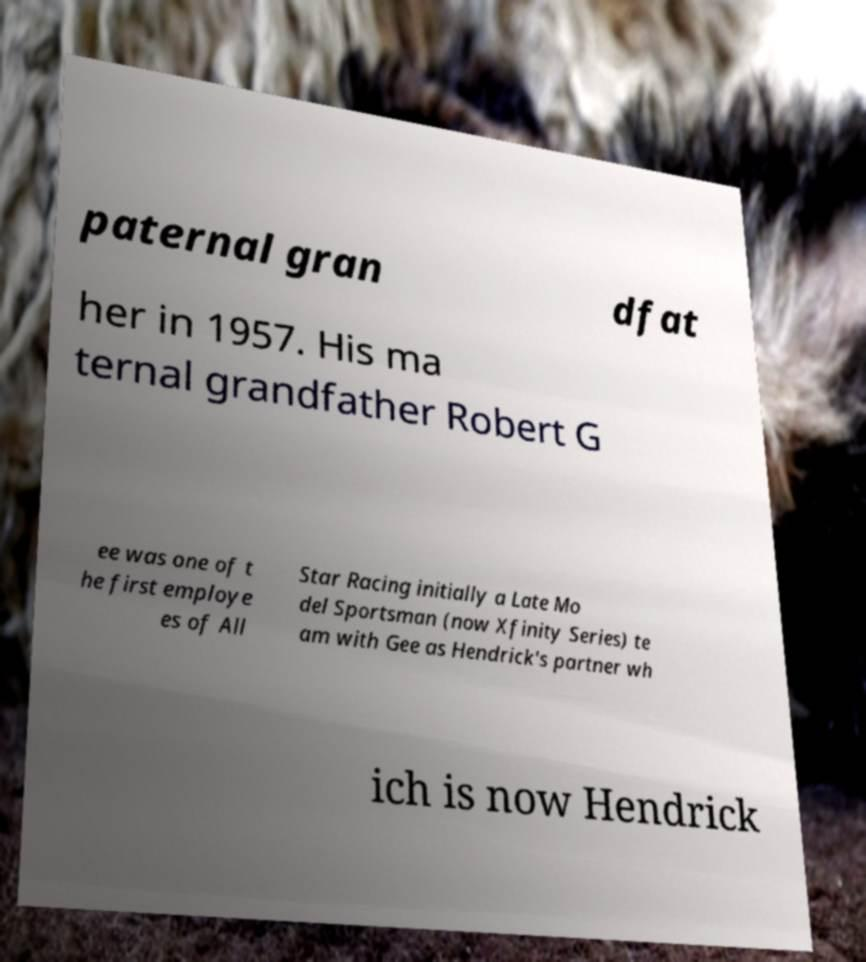Please identify and transcribe the text found in this image. paternal gran dfat her in 1957. His ma ternal grandfather Robert G ee was one of t he first employe es of All Star Racing initially a Late Mo del Sportsman (now Xfinity Series) te am with Gee as Hendrick's partner wh ich is now Hendrick 